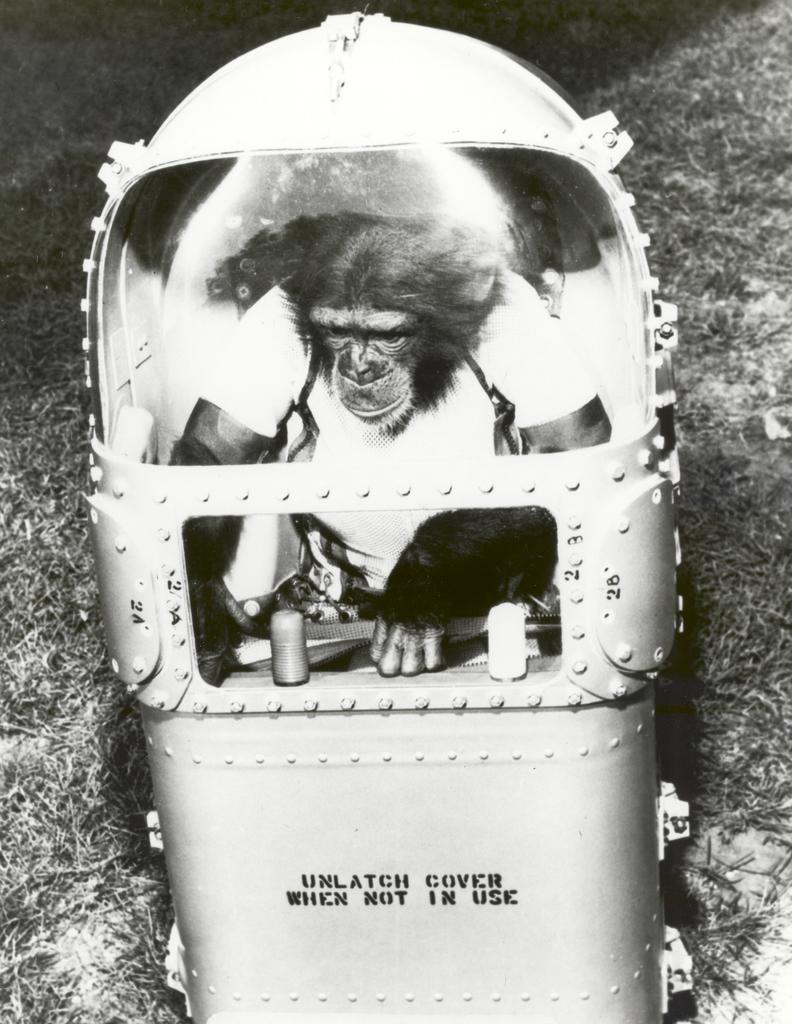Could you give a brief overview of what you see in this image? In the center of the image we can see monkey in a box. In the background we can see grass. 